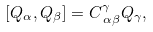Convert formula to latex. <formula><loc_0><loc_0><loc_500><loc_500>\left [ Q _ { \alpha } , Q _ { \beta } \right ] = C _ { \, \alpha \beta } ^ { \gamma } Q _ { \gamma } ,</formula> 